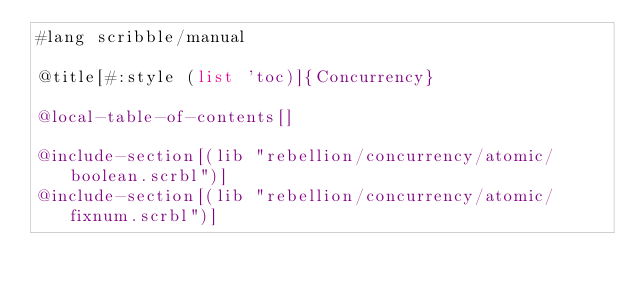<code> <loc_0><loc_0><loc_500><loc_500><_Racket_>#lang scribble/manual

@title[#:style (list 'toc)]{Concurrency}

@local-table-of-contents[]

@include-section[(lib "rebellion/concurrency/atomic/boolean.scrbl")]
@include-section[(lib "rebellion/concurrency/atomic/fixnum.scrbl")]
</code> 